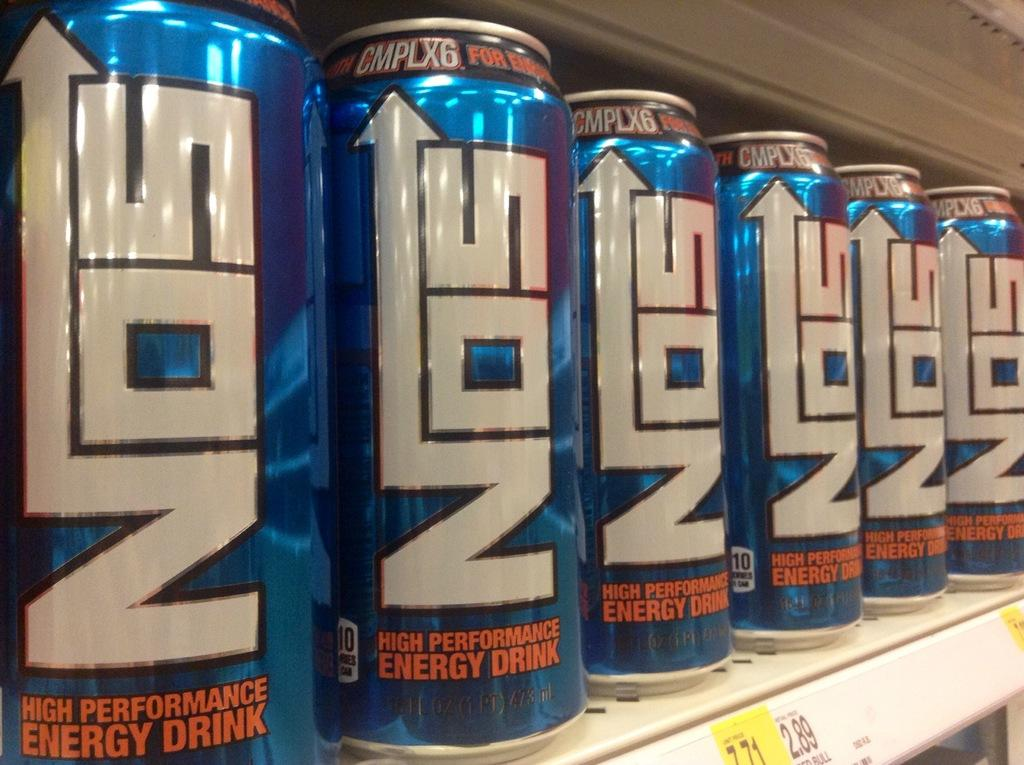<image>
Create a compact narrative representing the image presented. A row of blue Nos cans are lined up on a shop shelf. 